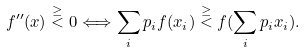<formula> <loc_0><loc_0><loc_500><loc_500>f ^ { \prime \prime } ( x ) \stackrel { \geq } { < } 0 \Longleftrightarrow \sum _ { i } p _ { i } f ( x _ { i } ) \stackrel { \geq } { < } f ( \sum _ { i } p _ { i } x _ { i } ) .</formula> 